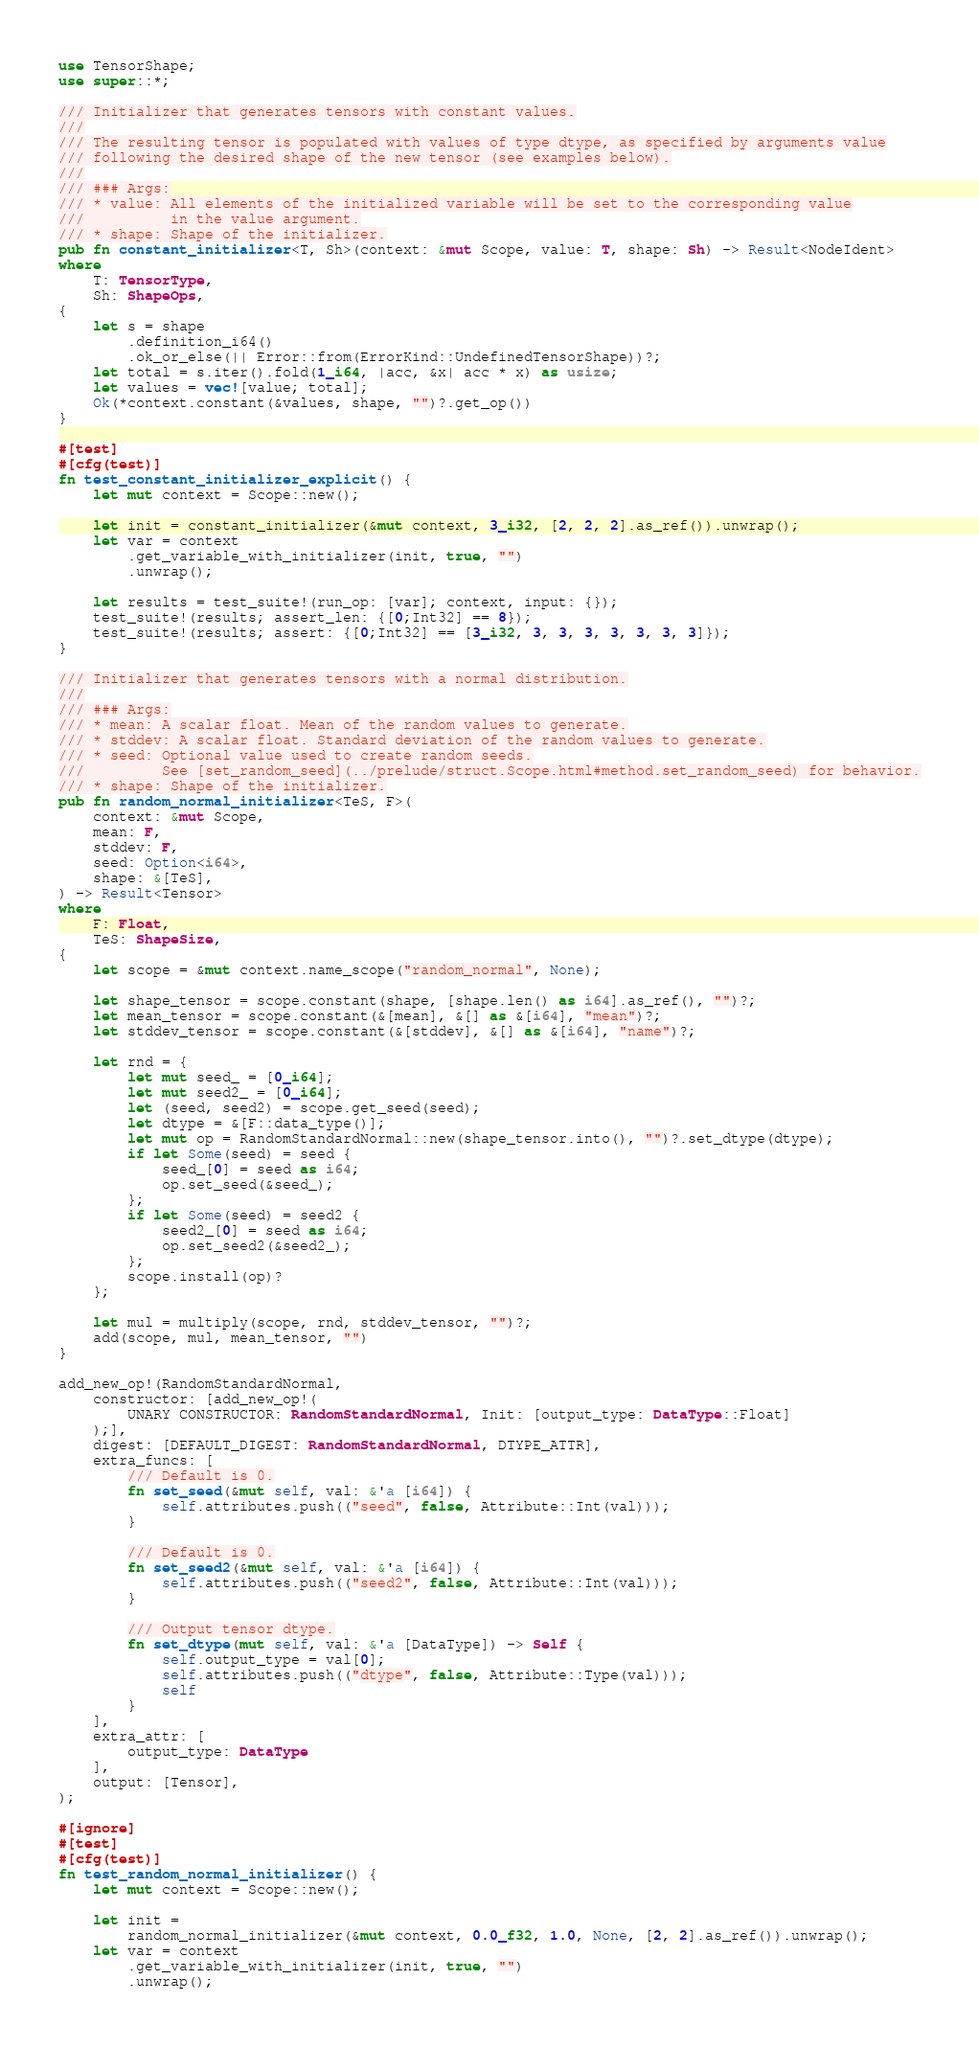<code> <loc_0><loc_0><loc_500><loc_500><_Rust_>use TensorShape;
use super::*;

/// Initializer that generates tensors with constant values.
///
/// The resulting tensor is populated with values of type dtype, as specified by arguments value
/// following the desired shape of the new tensor (see examples below).
///
/// ### Args:
/// * value: All elements of the initialized variable will be set to the corresponding value
///          in the value argument.
/// * shape: Shape of the initializer.
pub fn constant_initializer<T, Sh>(context: &mut Scope, value: T, shape: Sh) -> Result<NodeIdent>
where
    T: TensorType,
    Sh: ShapeOps,
{
    let s = shape
        .definition_i64()
        .ok_or_else(|| Error::from(ErrorKind::UndefinedTensorShape))?;
    let total = s.iter().fold(1_i64, |acc, &x| acc * x) as usize;
    let values = vec![value; total];
    Ok(*context.constant(&values, shape, "")?.get_op())
}

#[test]
#[cfg(test)]
fn test_constant_initializer_explicit() {
    let mut context = Scope::new();

    let init = constant_initializer(&mut context, 3_i32, [2, 2, 2].as_ref()).unwrap();
    let var = context
        .get_variable_with_initializer(init, true, "")
        .unwrap();

    let results = test_suite!(run_op: [var]; context, input: {});
    test_suite!(results; assert_len: {[0;Int32] == 8});
    test_suite!(results; assert: {[0;Int32] == [3_i32, 3, 3, 3, 3, 3, 3, 3]});
}

/// Initializer that generates tensors with a normal distribution.
///
/// ### Args:
/// * mean: A scalar float. Mean of the random values to generate.
/// * stddev: A scalar float. Standard deviation of the random values to generate.
/// * seed: Optional value used to create random seeds.
///         See [set_random_seed](../prelude/struct.Scope.html#method.set_random_seed) for behavior.
/// * shape: Shape of the initializer.
pub fn random_normal_initializer<TeS, F>(
    context: &mut Scope,
    mean: F,
    stddev: F,
    seed: Option<i64>,
    shape: &[TeS],
) -> Result<Tensor>
where
    F: Float,
    TeS: ShapeSize,
{
    let scope = &mut context.name_scope("random_normal", None);

    let shape_tensor = scope.constant(shape, [shape.len() as i64].as_ref(), "")?;
    let mean_tensor = scope.constant(&[mean], &[] as &[i64], "mean")?;
    let stddev_tensor = scope.constant(&[stddev], &[] as &[i64], "name")?;

    let rnd = {
        let mut seed_ = [0_i64];
        let mut seed2_ = [0_i64];
        let (seed, seed2) = scope.get_seed(seed);
        let dtype = &[F::data_type()];
        let mut op = RandomStandardNormal::new(shape_tensor.into(), "")?.set_dtype(dtype);
        if let Some(seed) = seed {
            seed_[0] = seed as i64;
            op.set_seed(&seed_);
        };
        if let Some(seed) = seed2 {
            seed2_[0] = seed as i64;
            op.set_seed2(&seed2_);
        };
        scope.install(op)?
    };

    let mul = multiply(scope, rnd, stddev_tensor, "")?;
    add(scope, mul, mean_tensor, "")
}

add_new_op!(RandomStandardNormal,
    constructor: [add_new_op!(
        UNARY CONSTRUCTOR: RandomStandardNormal, Init: [output_type: DataType::Float]
    );],
    digest: [DEFAULT_DIGEST: RandomStandardNormal, DTYPE_ATTR],
    extra_funcs: [
        /// Default is 0.
        fn set_seed(&mut self, val: &'a [i64]) {
            self.attributes.push(("seed", false, Attribute::Int(val)));
        }

        /// Default is 0.
        fn set_seed2(&mut self, val: &'a [i64]) {
            self.attributes.push(("seed2", false, Attribute::Int(val)));
        }

        /// Output tensor dtype.
        fn set_dtype(mut self, val: &'a [DataType]) -> Self {
            self.output_type = val[0];
            self.attributes.push(("dtype", false, Attribute::Type(val)));
            self
        }
    ], 
    extra_attr: [
        output_type: DataType
    ],
    output: [Tensor],
);

#[ignore]
#[test]
#[cfg(test)]
fn test_random_normal_initializer() {
    let mut context = Scope::new();

    let init =
        random_normal_initializer(&mut context, 0.0_f32, 1.0, None, [2, 2].as_ref()).unwrap();
    let var = context
        .get_variable_with_initializer(init, true, "")
        .unwrap();
</code> 